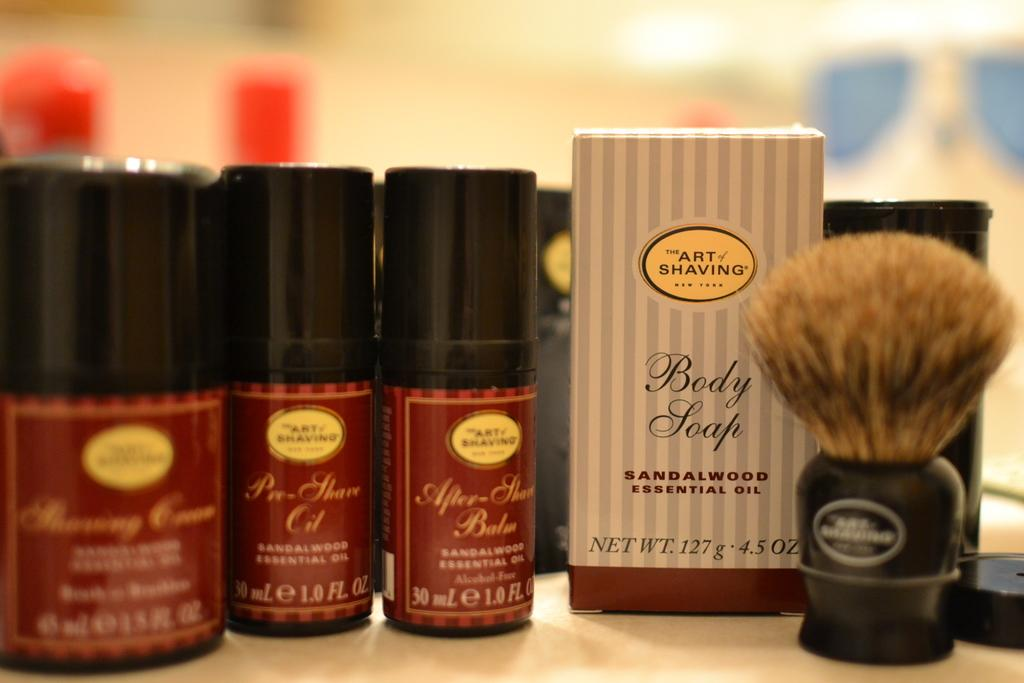Provide a one-sentence caption for the provided image. The Art of Shaving products with sandalwood essential oils next to a brush. 